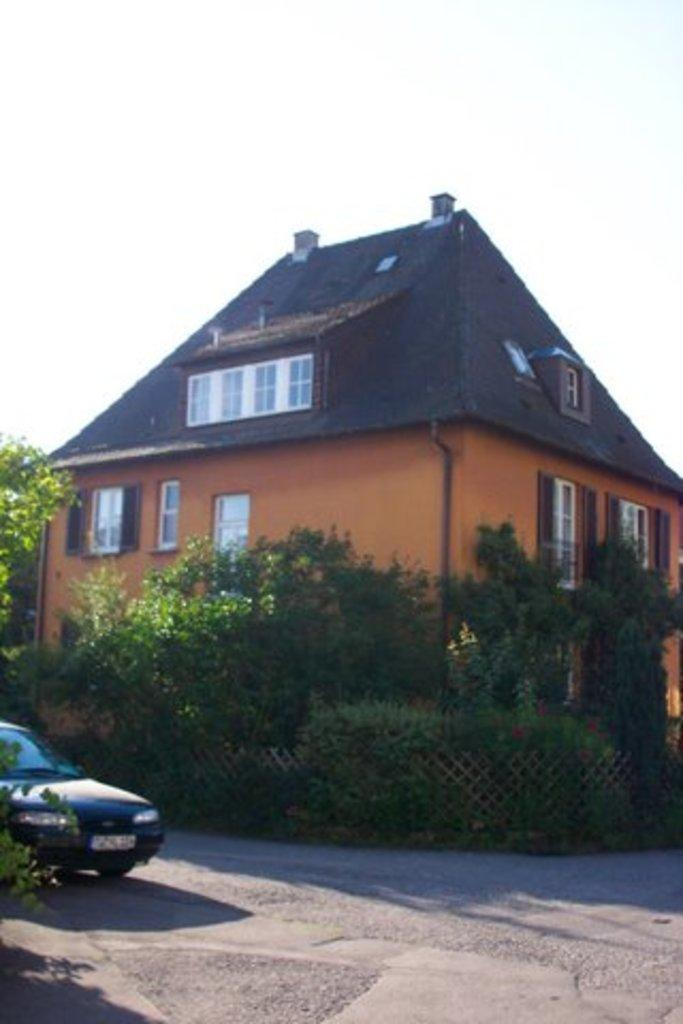What is the main subject of the image? There is a house at the center of the image. What can be seen in front of the house? There are trees in front of the house. Is there any vehicle visible in the image? Yes, there is a car parked in front of the house. What is visible in the background of the image? The sky is visible in the background of the image. How many hands are visible holding a watch in the image? There are no hands or watches visible in the image. What type of system is being used to control the house in the image? There is no indication of a system controlling the house in the image. 